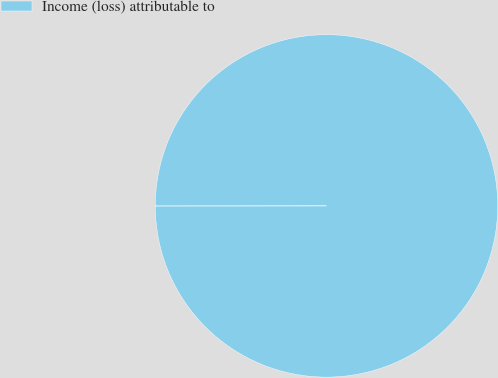Convert chart to OTSL. <chart><loc_0><loc_0><loc_500><loc_500><pie_chart><fcel>Income (loss) attributable to<nl><fcel>100.0%<nl></chart> 